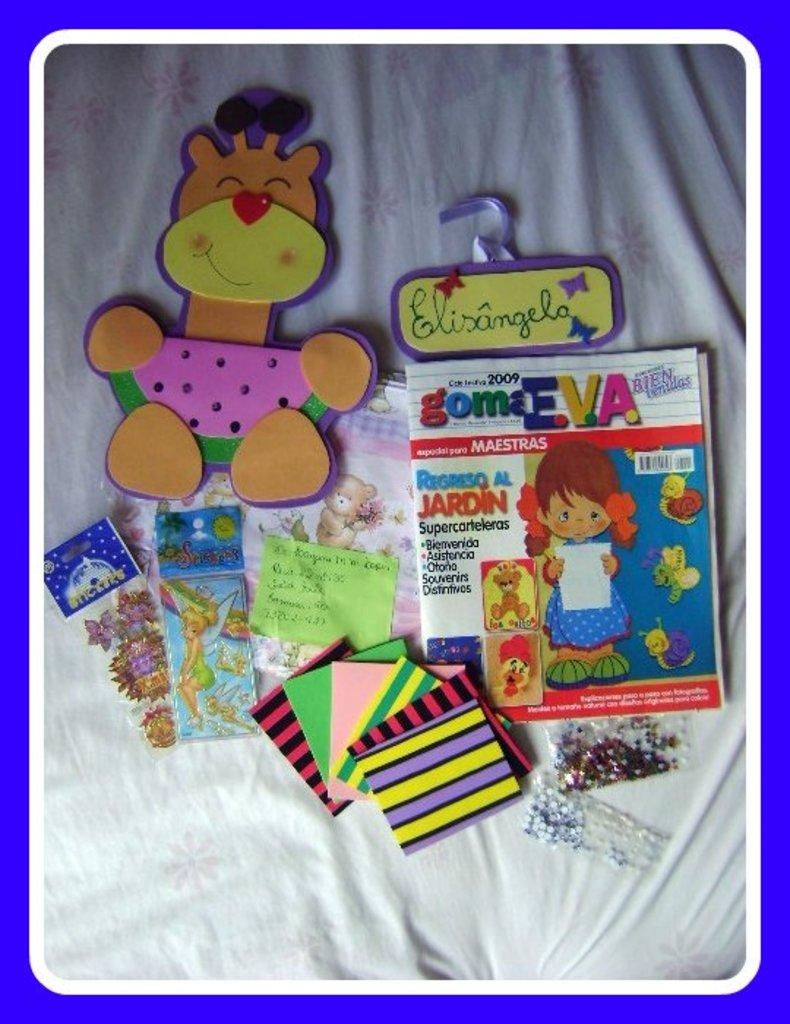What objects are located in the middle of the image? There are books, toys, papers, and stickers in the middle of the image. How many types of items can be seen in the middle of the image? There are four types of items: books, toys, papers, and stickers. What is at the bottom of the image? There is a blanket at the bottom of the image. Can you describe the arrangement of the items in the middle of the image? There are many items in the middle of the image, including books, toys, papers, and stickers. What type of brush is being used to paint the canvas in the image? There is no canvas or brush present in the image. Is the crown visible on the head of any person or object in the image? There is no crown present in the image. 